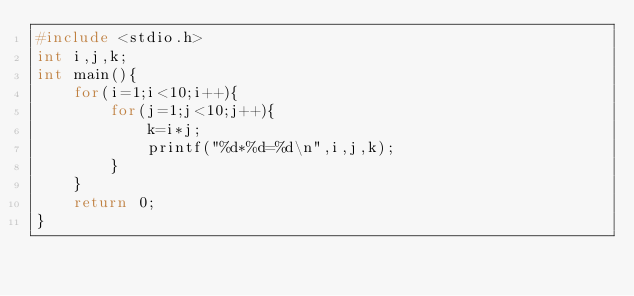Convert code to text. <code><loc_0><loc_0><loc_500><loc_500><_C_>#include <stdio.h>
int i,j,k;
int main(){
	for(i=1;i<10;i++){
		for(j=1;j<10;j++){
			k=i*j;
			printf("%d*%d=%d\n",i,j,k);
		}
	}
	return 0;
}</code> 